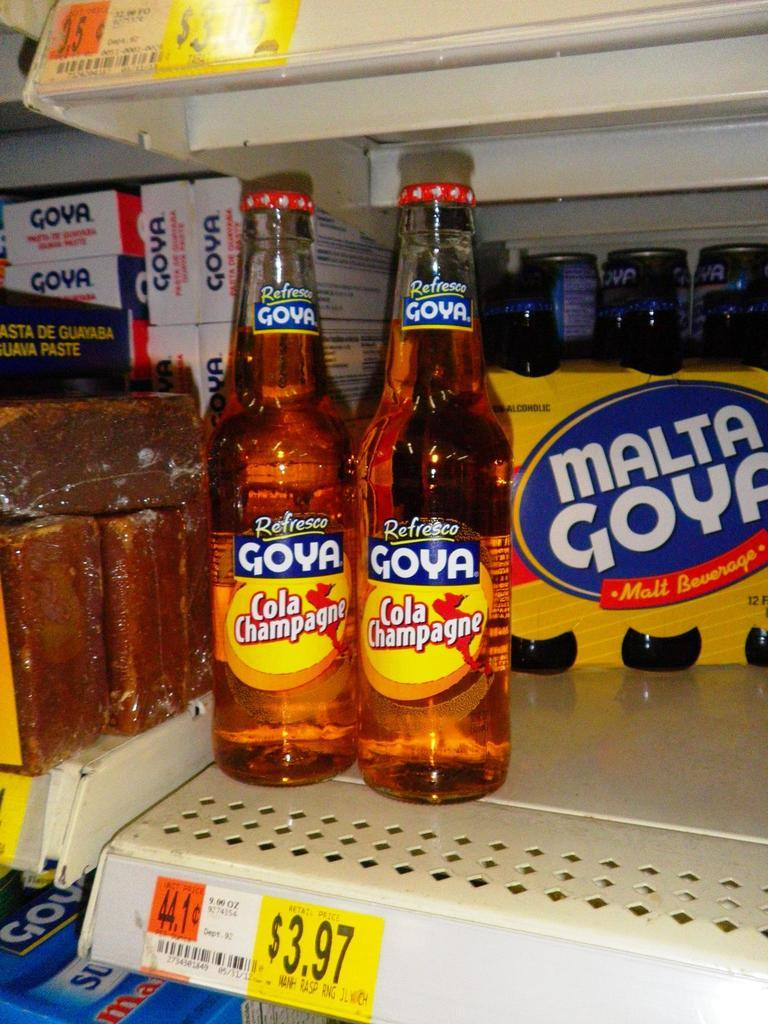<image>
Give a short and clear explanation of the subsequent image. Two bottles and a six pack Of Goya on a shelf with a labeled price tag of $3.97. 